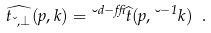<formula> <loc_0><loc_0><loc_500><loc_500>\widehat { t _ { \lambda , \bot } } ( p , k ) = \lambda ^ { d - \delta } \widehat { t } ( p , \lambda ^ { - 1 } k ) \ .</formula> 